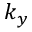<formula> <loc_0><loc_0><loc_500><loc_500>k _ { y }</formula> 